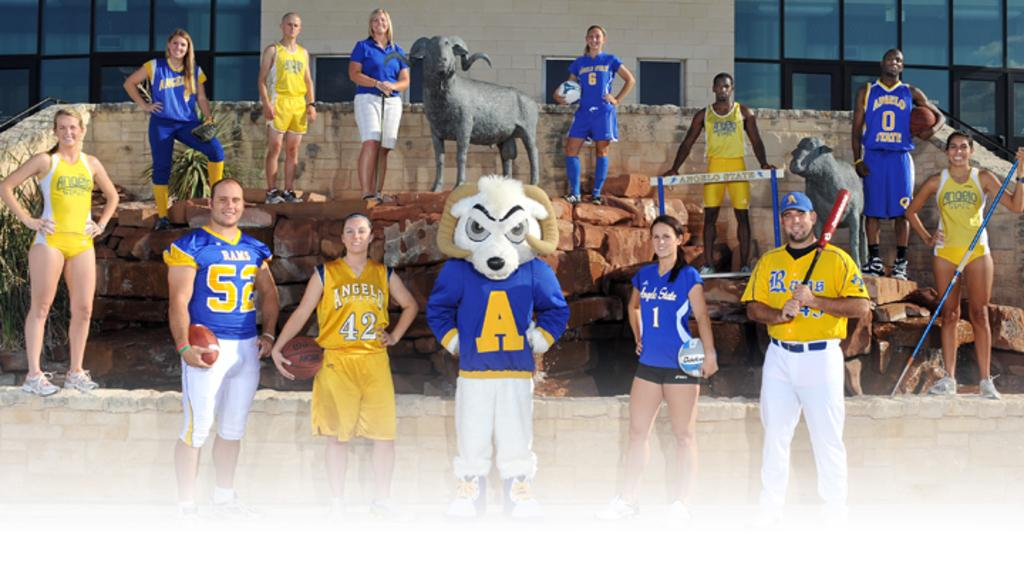Provide a one-sentence caption for the provided image. Athletes in blue and yellow costumes for various teams like the Rams and Angelo State. 